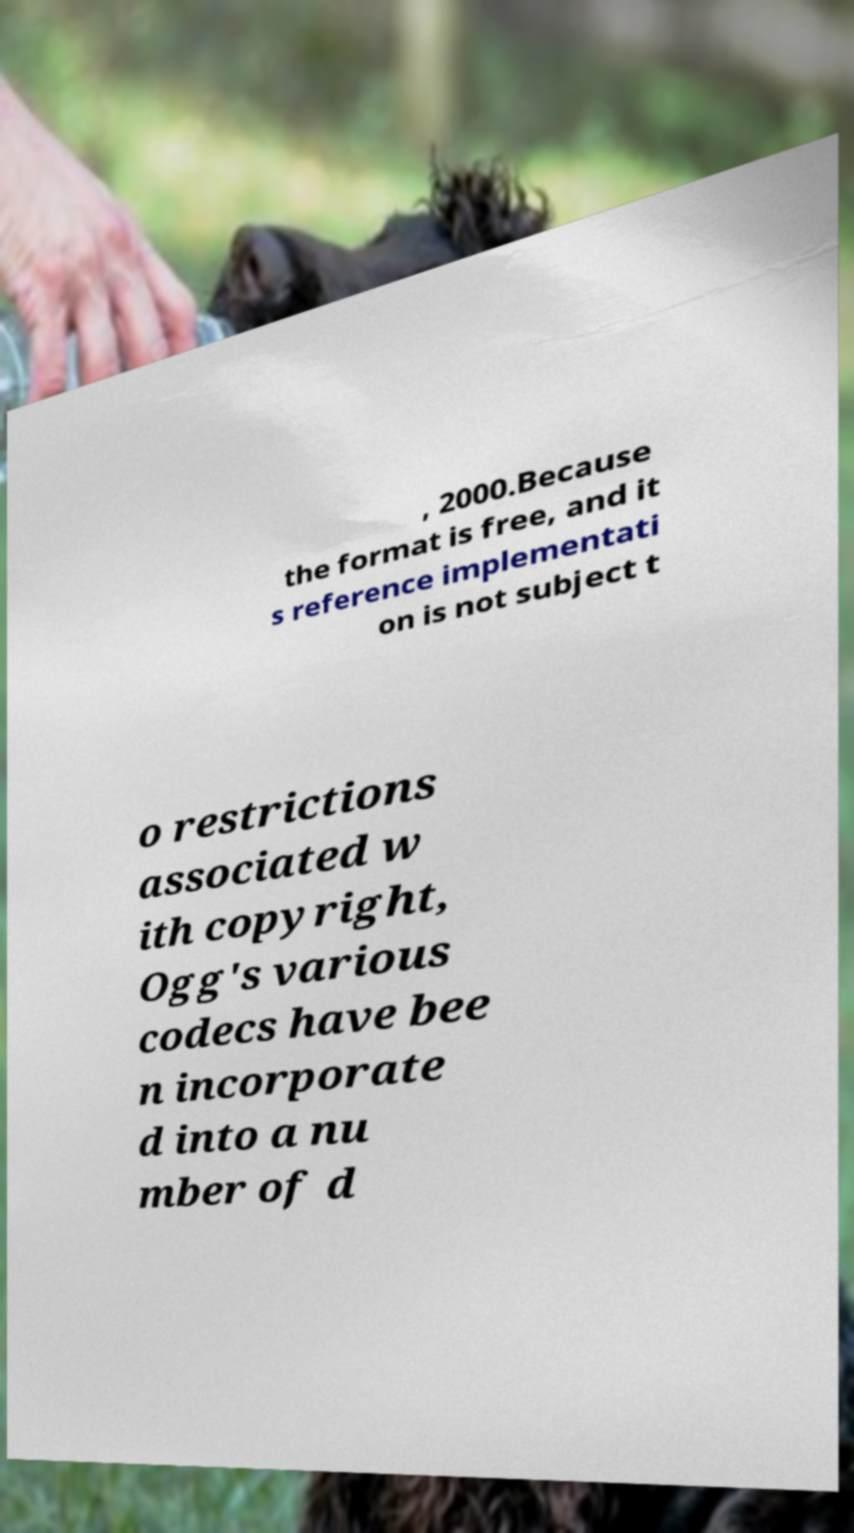Could you assist in decoding the text presented in this image and type it out clearly? , 2000.Because the format is free, and it s reference implementati on is not subject t o restrictions associated w ith copyright, Ogg's various codecs have bee n incorporate d into a nu mber of d 